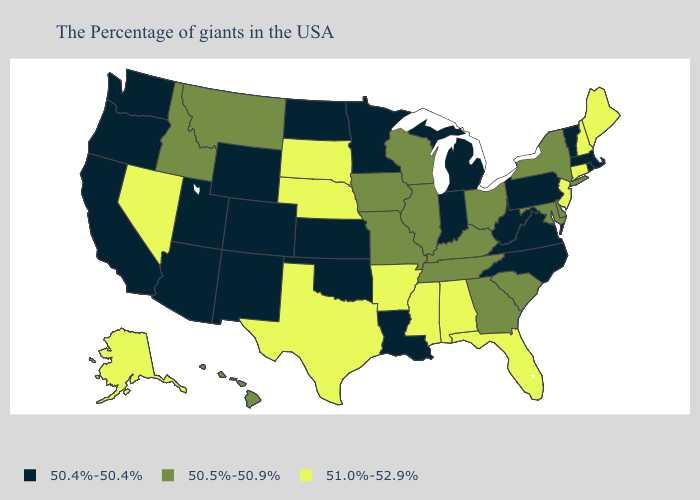What is the value of Iowa?
Short answer required. 50.5%-50.9%. What is the value of Wisconsin?
Short answer required. 50.5%-50.9%. Among the states that border North Dakota , does Minnesota have the highest value?
Concise answer only. No. Among the states that border Arizona , which have the lowest value?
Short answer required. Colorado, New Mexico, Utah, California. What is the value of Ohio?
Concise answer only. 50.5%-50.9%. What is the value of Mississippi?
Answer briefly. 51.0%-52.9%. Which states have the lowest value in the USA?
Concise answer only. Massachusetts, Rhode Island, Vermont, Pennsylvania, Virginia, North Carolina, West Virginia, Michigan, Indiana, Louisiana, Minnesota, Kansas, Oklahoma, North Dakota, Wyoming, Colorado, New Mexico, Utah, Arizona, California, Washington, Oregon. Does Colorado have a higher value than Rhode Island?
Keep it brief. No. What is the value of Vermont?
Answer briefly. 50.4%-50.4%. Which states have the lowest value in the South?
Give a very brief answer. Virginia, North Carolina, West Virginia, Louisiana, Oklahoma. Among the states that border Maine , which have the lowest value?
Write a very short answer. New Hampshire. What is the lowest value in the USA?
Short answer required. 50.4%-50.4%. What is the highest value in the MidWest ?
Quick response, please. 51.0%-52.9%. Which states have the highest value in the USA?
Answer briefly. Maine, New Hampshire, Connecticut, New Jersey, Florida, Alabama, Mississippi, Arkansas, Nebraska, Texas, South Dakota, Nevada, Alaska. What is the value of South Dakota?
Be succinct. 51.0%-52.9%. 